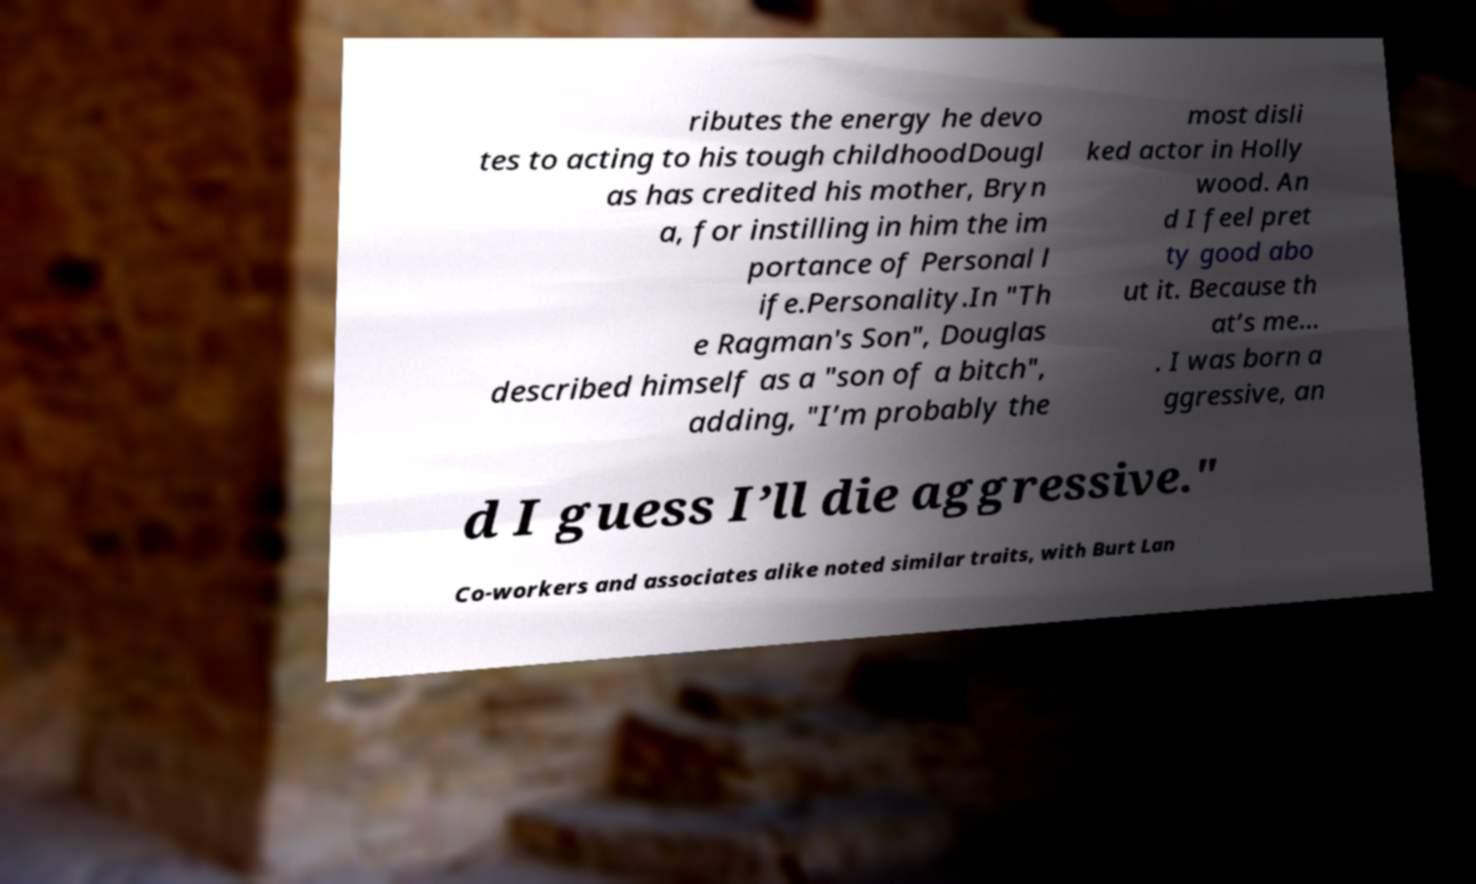There's text embedded in this image that I need extracted. Can you transcribe it verbatim? ributes the energy he devo tes to acting to his tough childhoodDougl as has credited his mother, Bryn a, for instilling in him the im portance of Personal l ife.Personality.In "Th e Ragman's Son", Douglas described himself as a "son of a bitch", adding, "I’m probably the most disli ked actor in Holly wood. An d I feel pret ty good abo ut it. Because th at’s me… . I was born a ggressive, an d I guess I’ll die aggressive." Co-workers and associates alike noted similar traits, with Burt Lan 